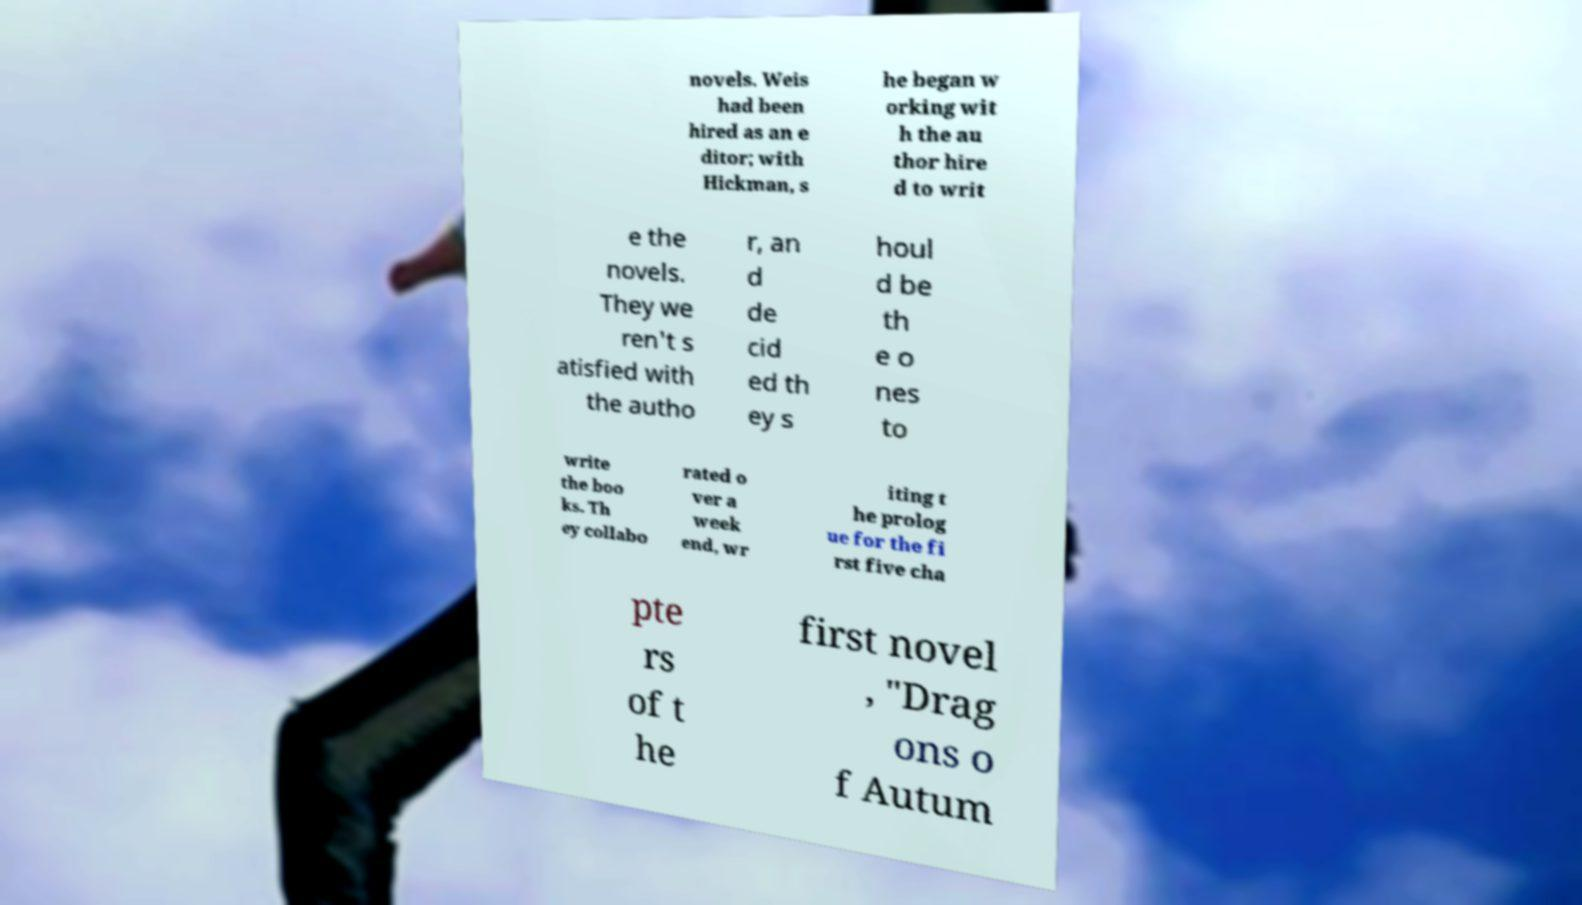Could you extract and type out the text from this image? novels. Weis had been hired as an e ditor; with Hickman, s he began w orking wit h the au thor hire d to writ e the novels. They we ren't s atisfied with the autho r, an d de cid ed th ey s houl d be th e o nes to write the boo ks. Th ey collabo rated o ver a week end, wr iting t he prolog ue for the fi rst five cha pte rs of t he first novel , "Drag ons o f Autum 